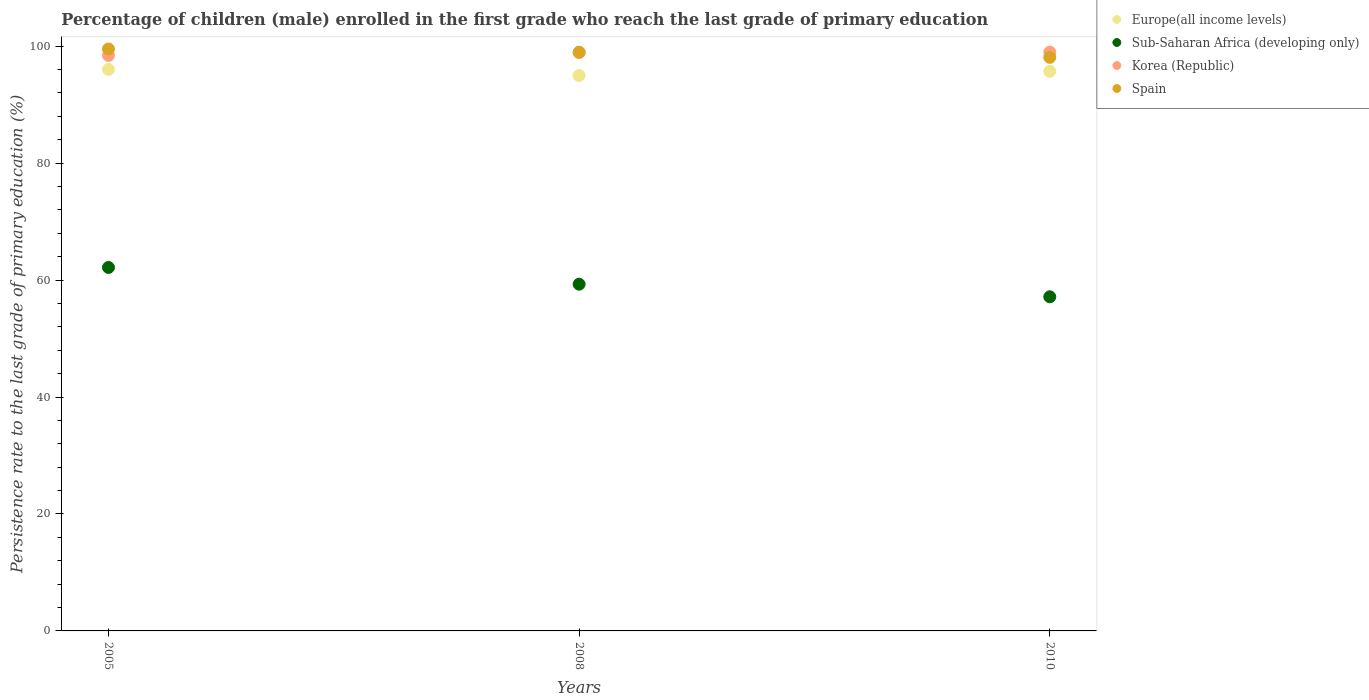How many different coloured dotlines are there?
Keep it short and to the point. 4. What is the persistence rate of children in Sub-Saharan Africa (developing only) in 2010?
Provide a short and direct response. 57.14. Across all years, what is the maximum persistence rate of children in Sub-Saharan Africa (developing only)?
Your response must be concise. 62.16. Across all years, what is the minimum persistence rate of children in Sub-Saharan Africa (developing only)?
Offer a very short reply. 57.14. In which year was the persistence rate of children in Sub-Saharan Africa (developing only) minimum?
Make the answer very short. 2010. What is the total persistence rate of children in Europe(all income levels) in the graph?
Offer a very short reply. 286.7. What is the difference between the persistence rate of children in Korea (Republic) in 2005 and that in 2008?
Offer a very short reply. -0.51. What is the difference between the persistence rate of children in Sub-Saharan Africa (developing only) in 2005 and the persistence rate of children in Europe(all income levels) in 2008?
Give a very brief answer. -32.82. What is the average persistence rate of children in Spain per year?
Ensure brevity in your answer.  98.85. In the year 2010, what is the difference between the persistence rate of children in Sub-Saharan Africa (developing only) and persistence rate of children in Europe(all income levels)?
Your answer should be very brief. -38.55. In how many years, is the persistence rate of children in Spain greater than 28 %?
Your answer should be very brief. 3. What is the ratio of the persistence rate of children in Europe(all income levels) in 2005 to that in 2008?
Provide a short and direct response. 1.01. Is the difference between the persistence rate of children in Sub-Saharan Africa (developing only) in 2005 and 2010 greater than the difference between the persistence rate of children in Europe(all income levels) in 2005 and 2010?
Your response must be concise. Yes. What is the difference between the highest and the second highest persistence rate of children in Sub-Saharan Africa (developing only)?
Provide a succinct answer. 2.86. What is the difference between the highest and the lowest persistence rate of children in Europe(all income levels)?
Make the answer very short. 1.05. Is the sum of the persistence rate of children in Korea (Republic) in 2005 and 2010 greater than the maximum persistence rate of children in Spain across all years?
Your response must be concise. Yes. Is it the case that in every year, the sum of the persistence rate of children in Korea (Republic) and persistence rate of children in Europe(all income levels)  is greater than the sum of persistence rate of children in Spain and persistence rate of children in Sub-Saharan Africa (developing only)?
Your answer should be very brief. Yes. Does the persistence rate of children in Sub-Saharan Africa (developing only) monotonically increase over the years?
Your response must be concise. No. What is the difference between two consecutive major ticks on the Y-axis?
Offer a terse response. 20. Does the graph contain any zero values?
Give a very brief answer. No. How are the legend labels stacked?
Your answer should be very brief. Vertical. What is the title of the graph?
Keep it short and to the point. Percentage of children (male) enrolled in the first grade who reach the last grade of primary education. Does "Congo (Democratic)" appear as one of the legend labels in the graph?
Your answer should be compact. No. What is the label or title of the Y-axis?
Provide a short and direct response. Persistence rate to the last grade of primary education (%). What is the Persistence rate to the last grade of primary education (%) of Europe(all income levels) in 2005?
Your answer should be very brief. 96.03. What is the Persistence rate to the last grade of primary education (%) in Sub-Saharan Africa (developing only) in 2005?
Keep it short and to the point. 62.16. What is the Persistence rate to the last grade of primary education (%) in Korea (Republic) in 2005?
Ensure brevity in your answer.  98.41. What is the Persistence rate to the last grade of primary education (%) of Spain in 2005?
Provide a succinct answer. 99.52. What is the Persistence rate to the last grade of primary education (%) of Europe(all income levels) in 2008?
Ensure brevity in your answer.  94.98. What is the Persistence rate to the last grade of primary education (%) in Sub-Saharan Africa (developing only) in 2008?
Your answer should be very brief. 59.29. What is the Persistence rate to the last grade of primary education (%) in Korea (Republic) in 2008?
Your answer should be very brief. 98.91. What is the Persistence rate to the last grade of primary education (%) in Spain in 2008?
Ensure brevity in your answer.  98.96. What is the Persistence rate to the last grade of primary education (%) of Europe(all income levels) in 2010?
Provide a succinct answer. 95.69. What is the Persistence rate to the last grade of primary education (%) of Sub-Saharan Africa (developing only) in 2010?
Offer a terse response. 57.14. What is the Persistence rate to the last grade of primary education (%) of Korea (Republic) in 2010?
Ensure brevity in your answer.  98.98. What is the Persistence rate to the last grade of primary education (%) of Spain in 2010?
Keep it short and to the point. 98.08. Across all years, what is the maximum Persistence rate to the last grade of primary education (%) of Europe(all income levels)?
Offer a terse response. 96.03. Across all years, what is the maximum Persistence rate to the last grade of primary education (%) in Sub-Saharan Africa (developing only)?
Your response must be concise. 62.16. Across all years, what is the maximum Persistence rate to the last grade of primary education (%) of Korea (Republic)?
Offer a terse response. 98.98. Across all years, what is the maximum Persistence rate to the last grade of primary education (%) in Spain?
Give a very brief answer. 99.52. Across all years, what is the minimum Persistence rate to the last grade of primary education (%) of Europe(all income levels)?
Your response must be concise. 94.98. Across all years, what is the minimum Persistence rate to the last grade of primary education (%) of Sub-Saharan Africa (developing only)?
Provide a short and direct response. 57.14. Across all years, what is the minimum Persistence rate to the last grade of primary education (%) of Korea (Republic)?
Ensure brevity in your answer.  98.41. Across all years, what is the minimum Persistence rate to the last grade of primary education (%) in Spain?
Offer a very short reply. 98.08. What is the total Persistence rate to the last grade of primary education (%) in Europe(all income levels) in the graph?
Offer a very short reply. 286.7. What is the total Persistence rate to the last grade of primary education (%) of Sub-Saharan Africa (developing only) in the graph?
Provide a short and direct response. 178.59. What is the total Persistence rate to the last grade of primary education (%) of Korea (Republic) in the graph?
Offer a terse response. 296.3. What is the total Persistence rate to the last grade of primary education (%) of Spain in the graph?
Your answer should be compact. 296.56. What is the difference between the Persistence rate to the last grade of primary education (%) in Europe(all income levels) in 2005 and that in 2008?
Keep it short and to the point. 1.05. What is the difference between the Persistence rate to the last grade of primary education (%) of Sub-Saharan Africa (developing only) in 2005 and that in 2008?
Keep it short and to the point. 2.86. What is the difference between the Persistence rate to the last grade of primary education (%) of Korea (Republic) in 2005 and that in 2008?
Your answer should be very brief. -0.51. What is the difference between the Persistence rate to the last grade of primary education (%) in Spain in 2005 and that in 2008?
Ensure brevity in your answer.  0.55. What is the difference between the Persistence rate to the last grade of primary education (%) in Europe(all income levels) in 2005 and that in 2010?
Make the answer very short. 0.34. What is the difference between the Persistence rate to the last grade of primary education (%) of Sub-Saharan Africa (developing only) in 2005 and that in 2010?
Offer a very short reply. 5.02. What is the difference between the Persistence rate to the last grade of primary education (%) of Korea (Republic) in 2005 and that in 2010?
Offer a very short reply. -0.57. What is the difference between the Persistence rate to the last grade of primary education (%) in Spain in 2005 and that in 2010?
Offer a very short reply. 1.44. What is the difference between the Persistence rate to the last grade of primary education (%) in Europe(all income levels) in 2008 and that in 2010?
Provide a succinct answer. -0.72. What is the difference between the Persistence rate to the last grade of primary education (%) in Sub-Saharan Africa (developing only) in 2008 and that in 2010?
Ensure brevity in your answer.  2.16. What is the difference between the Persistence rate to the last grade of primary education (%) of Korea (Republic) in 2008 and that in 2010?
Provide a succinct answer. -0.06. What is the difference between the Persistence rate to the last grade of primary education (%) in Spain in 2008 and that in 2010?
Make the answer very short. 0.88. What is the difference between the Persistence rate to the last grade of primary education (%) in Europe(all income levels) in 2005 and the Persistence rate to the last grade of primary education (%) in Sub-Saharan Africa (developing only) in 2008?
Your response must be concise. 36.74. What is the difference between the Persistence rate to the last grade of primary education (%) in Europe(all income levels) in 2005 and the Persistence rate to the last grade of primary education (%) in Korea (Republic) in 2008?
Give a very brief answer. -2.88. What is the difference between the Persistence rate to the last grade of primary education (%) of Europe(all income levels) in 2005 and the Persistence rate to the last grade of primary education (%) of Spain in 2008?
Provide a succinct answer. -2.93. What is the difference between the Persistence rate to the last grade of primary education (%) of Sub-Saharan Africa (developing only) in 2005 and the Persistence rate to the last grade of primary education (%) of Korea (Republic) in 2008?
Provide a short and direct response. -36.76. What is the difference between the Persistence rate to the last grade of primary education (%) in Sub-Saharan Africa (developing only) in 2005 and the Persistence rate to the last grade of primary education (%) in Spain in 2008?
Keep it short and to the point. -36.81. What is the difference between the Persistence rate to the last grade of primary education (%) in Korea (Republic) in 2005 and the Persistence rate to the last grade of primary education (%) in Spain in 2008?
Your response must be concise. -0.55. What is the difference between the Persistence rate to the last grade of primary education (%) in Europe(all income levels) in 2005 and the Persistence rate to the last grade of primary education (%) in Sub-Saharan Africa (developing only) in 2010?
Your response must be concise. 38.89. What is the difference between the Persistence rate to the last grade of primary education (%) in Europe(all income levels) in 2005 and the Persistence rate to the last grade of primary education (%) in Korea (Republic) in 2010?
Provide a succinct answer. -2.95. What is the difference between the Persistence rate to the last grade of primary education (%) of Europe(all income levels) in 2005 and the Persistence rate to the last grade of primary education (%) of Spain in 2010?
Ensure brevity in your answer.  -2.05. What is the difference between the Persistence rate to the last grade of primary education (%) of Sub-Saharan Africa (developing only) in 2005 and the Persistence rate to the last grade of primary education (%) of Korea (Republic) in 2010?
Offer a very short reply. -36.82. What is the difference between the Persistence rate to the last grade of primary education (%) of Sub-Saharan Africa (developing only) in 2005 and the Persistence rate to the last grade of primary education (%) of Spain in 2010?
Make the answer very short. -35.92. What is the difference between the Persistence rate to the last grade of primary education (%) in Korea (Republic) in 2005 and the Persistence rate to the last grade of primary education (%) in Spain in 2010?
Offer a very short reply. 0.33. What is the difference between the Persistence rate to the last grade of primary education (%) in Europe(all income levels) in 2008 and the Persistence rate to the last grade of primary education (%) in Sub-Saharan Africa (developing only) in 2010?
Your answer should be very brief. 37.84. What is the difference between the Persistence rate to the last grade of primary education (%) of Europe(all income levels) in 2008 and the Persistence rate to the last grade of primary education (%) of Korea (Republic) in 2010?
Your answer should be compact. -4. What is the difference between the Persistence rate to the last grade of primary education (%) of Europe(all income levels) in 2008 and the Persistence rate to the last grade of primary education (%) of Spain in 2010?
Your answer should be compact. -3.1. What is the difference between the Persistence rate to the last grade of primary education (%) in Sub-Saharan Africa (developing only) in 2008 and the Persistence rate to the last grade of primary education (%) in Korea (Republic) in 2010?
Give a very brief answer. -39.68. What is the difference between the Persistence rate to the last grade of primary education (%) in Sub-Saharan Africa (developing only) in 2008 and the Persistence rate to the last grade of primary education (%) in Spain in 2010?
Offer a very short reply. -38.79. What is the difference between the Persistence rate to the last grade of primary education (%) in Korea (Republic) in 2008 and the Persistence rate to the last grade of primary education (%) in Spain in 2010?
Make the answer very short. 0.83. What is the average Persistence rate to the last grade of primary education (%) of Europe(all income levels) per year?
Your response must be concise. 95.57. What is the average Persistence rate to the last grade of primary education (%) of Sub-Saharan Africa (developing only) per year?
Your answer should be very brief. 59.53. What is the average Persistence rate to the last grade of primary education (%) of Korea (Republic) per year?
Offer a terse response. 98.77. What is the average Persistence rate to the last grade of primary education (%) in Spain per year?
Your answer should be very brief. 98.85. In the year 2005, what is the difference between the Persistence rate to the last grade of primary education (%) in Europe(all income levels) and Persistence rate to the last grade of primary education (%) in Sub-Saharan Africa (developing only)?
Provide a short and direct response. 33.87. In the year 2005, what is the difference between the Persistence rate to the last grade of primary education (%) of Europe(all income levels) and Persistence rate to the last grade of primary education (%) of Korea (Republic)?
Your response must be concise. -2.38. In the year 2005, what is the difference between the Persistence rate to the last grade of primary education (%) of Europe(all income levels) and Persistence rate to the last grade of primary education (%) of Spain?
Make the answer very short. -3.49. In the year 2005, what is the difference between the Persistence rate to the last grade of primary education (%) of Sub-Saharan Africa (developing only) and Persistence rate to the last grade of primary education (%) of Korea (Republic)?
Offer a terse response. -36.25. In the year 2005, what is the difference between the Persistence rate to the last grade of primary education (%) of Sub-Saharan Africa (developing only) and Persistence rate to the last grade of primary education (%) of Spain?
Provide a short and direct response. -37.36. In the year 2005, what is the difference between the Persistence rate to the last grade of primary education (%) of Korea (Republic) and Persistence rate to the last grade of primary education (%) of Spain?
Ensure brevity in your answer.  -1.11. In the year 2008, what is the difference between the Persistence rate to the last grade of primary education (%) in Europe(all income levels) and Persistence rate to the last grade of primary education (%) in Sub-Saharan Africa (developing only)?
Provide a succinct answer. 35.68. In the year 2008, what is the difference between the Persistence rate to the last grade of primary education (%) in Europe(all income levels) and Persistence rate to the last grade of primary education (%) in Korea (Republic)?
Make the answer very short. -3.94. In the year 2008, what is the difference between the Persistence rate to the last grade of primary education (%) of Europe(all income levels) and Persistence rate to the last grade of primary education (%) of Spain?
Your answer should be compact. -3.99. In the year 2008, what is the difference between the Persistence rate to the last grade of primary education (%) of Sub-Saharan Africa (developing only) and Persistence rate to the last grade of primary education (%) of Korea (Republic)?
Offer a terse response. -39.62. In the year 2008, what is the difference between the Persistence rate to the last grade of primary education (%) of Sub-Saharan Africa (developing only) and Persistence rate to the last grade of primary education (%) of Spain?
Your answer should be very brief. -39.67. In the year 2008, what is the difference between the Persistence rate to the last grade of primary education (%) of Korea (Republic) and Persistence rate to the last grade of primary education (%) of Spain?
Provide a short and direct response. -0.05. In the year 2010, what is the difference between the Persistence rate to the last grade of primary education (%) in Europe(all income levels) and Persistence rate to the last grade of primary education (%) in Sub-Saharan Africa (developing only)?
Your response must be concise. 38.55. In the year 2010, what is the difference between the Persistence rate to the last grade of primary education (%) in Europe(all income levels) and Persistence rate to the last grade of primary education (%) in Korea (Republic)?
Give a very brief answer. -3.28. In the year 2010, what is the difference between the Persistence rate to the last grade of primary education (%) of Europe(all income levels) and Persistence rate to the last grade of primary education (%) of Spain?
Provide a succinct answer. -2.39. In the year 2010, what is the difference between the Persistence rate to the last grade of primary education (%) of Sub-Saharan Africa (developing only) and Persistence rate to the last grade of primary education (%) of Korea (Republic)?
Offer a terse response. -41.84. In the year 2010, what is the difference between the Persistence rate to the last grade of primary education (%) in Sub-Saharan Africa (developing only) and Persistence rate to the last grade of primary education (%) in Spain?
Offer a very short reply. -40.94. In the year 2010, what is the difference between the Persistence rate to the last grade of primary education (%) in Korea (Republic) and Persistence rate to the last grade of primary education (%) in Spain?
Your response must be concise. 0.9. What is the ratio of the Persistence rate to the last grade of primary education (%) in Europe(all income levels) in 2005 to that in 2008?
Offer a very short reply. 1.01. What is the ratio of the Persistence rate to the last grade of primary education (%) of Sub-Saharan Africa (developing only) in 2005 to that in 2008?
Provide a short and direct response. 1.05. What is the ratio of the Persistence rate to the last grade of primary education (%) in Spain in 2005 to that in 2008?
Provide a short and direct response. 1.01. What is the ratio of the Persistence rate to the last grade of primary education (%) in Sub-Saharan Africa (developing only) in 2005 to that in 2010?
Ensure brevity in your answer.  1.09. What is the ratio of the Persistence rate to the last grade of primary education (%) of Korea (Republic) in 2005 to that in 2010?
Keep it short and to the point. 0.99. What is the ratio of the Persistence rate to the last grade of primary education (%) in Spain in 2005 to that in 2010?
Provide a short and direct response. 1.01. What is the ratio of the Persistence rate to the last grade of primary education (%) of Sub-Saharan Africa (developing only) in 2008 to that in 2010?
Ensure brevity in your answer.  1.04. What is the ratio of the Persistence rate to the last grade of primary education (%) in Spain in 2008 to that in 2010?
Provide a succinct answer. 1.01. What is the difference between the highest and the second highest Persistence rate to the last grade of primary education (%) of Europe(all income levels)?
Offer a terse response. 0.34. What is the difference between the highest and the second highest Persistence rate to the last grade of primary education (%) in Sub-Saharan Africa (developing only)?
Keep it short and to the point. 2.86. What is the difference between the highest and the second highest Persistence rate to the last grade of primary education (%) of Korea (Republic)?
Give a very brief answer. 0.06. What is the difference between the highest and the second highest Persistence rate to the last grade of primary education (%) of Spain?
Give a very brief answer. 0.55. What is the difference between the highest and the lowest Persistence rate to the last grade of primary education (%) in Europe(all income levels)?
Keep it short and to the point. 1.05. What is the difference between the highest and the lowest Persistence rate to the last grade of primary education (%) of Sub-Saharan Africa (developing only)?
Your answer should be very brief. 5.02. What is the difference between the highest and the lowest Persistence rate to the last grade of primary education (%) in Korea (Republic)?
Ensure brevity in your answer.  0.57. What is the difference between the highest and the lowest Persistence rate to the last grade of primary education (%) of Spain?
Your answer should be very brief. 1.44. 